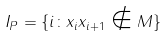<formula> <loc_0><loc_0><loc_500><loc_500>I _ { P } = \{ i \colon x _ { i } x _ { i + 1 } \notin M \}</formula> 